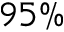<formula> <loc_0><loc_0><loc_500><loc_500>9 5 \%</formula> 